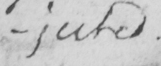What text is written in this handwritten line? -jected . 